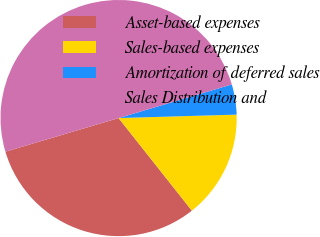Convert chart. <chart><loc_0><loc_0><loc_500><loc_500><pie_chart><fcel>Asset-based expenses<fcel>Sales-based expenses<fcel>Amortization of deferred sales<fcel>Sales Distribution and<nl><fcel>31.06%<fcel>14.81%<fcel>4.13%<fcel>50.0%<nl></chart> 